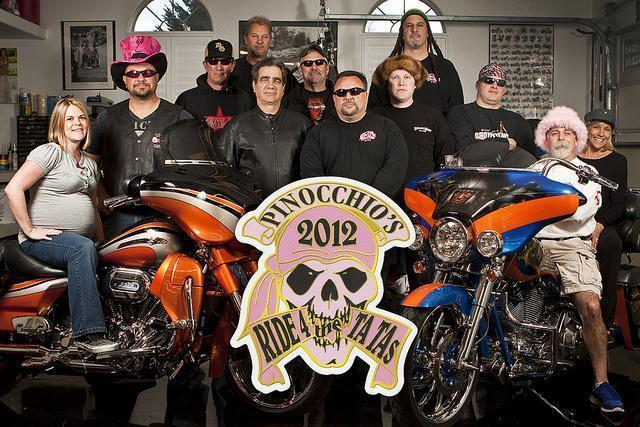What type of cancer charity are they supporting?
Pick the right solution, then justify: 'Answer: answer
Rationale: rationale.'
Options: Lung, breast, liver, pancreatic. Answer: breast.
Rationale: The color of this organization is often pink, the color featured in the sign.  the word ta ta represents the part of the body for this organization. 